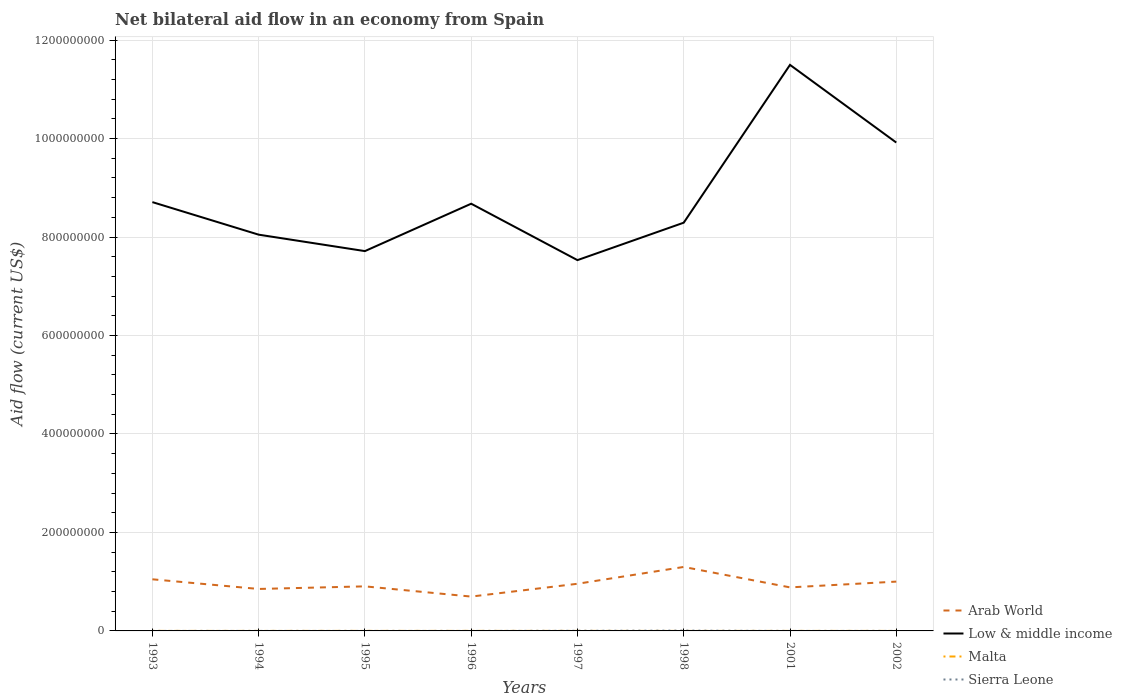In which year was the net bilateral aid flow in Arab World maximum?
Give a very brief answer. 1996. What is the total net bilateral aid flow in Sierra Leone in the graph?
Provide a succinct answer. -2.70e+05. What is the difference between the highest and the second highest net bilateral aid flow in Arab World?
Your response must be concise. 6.02e+07. Does the graph contain grids?
Your answer should be very brief. Yes. How many legend labels are there?
Your answer should be very brief. 4. How are the legend labels stacked?
Provide a succinct answer. Vertical. What is the title of the graph?
Offer a terse response. Net bilateral aid flow in an economy from Spain. Does "Iceland" appear as one of the legend labels in the graph?
Offer a terse response. No. What is the label or title of the X-axis?
Provide a short and direct response. Years. What is the Aid flow (current US$) of Arab World in 1993?
Your response must be concise. 1.05e+08. What is the Aid flow (current US$) in Low & middle income in 1993?
Provide a short and direct response. 8.71e+08. What is the Aid flow (current US$) in Malta in 1993?
Offer a very short reply. 5.00e+04. What is the Aid flow (current US$) in Arab World in 1994?
Provide a succinct answer. 8.52e+07. What is the Aid flow (current US$) in Low & middle income in 1994?
Your answer should be very brief. 8.05e+08. What is the Aid flow (current US$) in Malta in 1994?
Offer a very short reply. 4.00e+04. What is the Aid flow (current US$) in Sierra Leone in 1994?
Your answer should be compact. 2.00e+04. What is the Aid flow (current US$) in Arab World in 1995?
Offer a very short reply. 9.05e+07. What is the Aid flow (current US$) of Low & middle income in 1995?
Your response must be concise. 7.71e+08. What is the Aid flow (current US$) of Sierra Leone in 1995?
Keep it short and to the point. 3.00e+04. What is the Aid flow (current US$) in Arab World in 1996?
Keep it short and to the point. 6.98e+07. What is the Aid flow (current US$) of Low & middle income in 1996?
Provide a short and direct response. 8.68e+08. What is the Aid flow (current US$) in Arab World in 1997?
Your answer should be compact. 9.58e+07. What is the Aid flow (current US$) in Low & middle income in 1997?
Your answer should be compact. 7.53e+08. What is the Aid flow (current US$) in Malta in 1997?
Your response must be concise. 6.00e+04. What is the Aid flow (current US$) of Sierra Leone in 1997?
Offer a terse response. 3.00e+05. What is the Aid flow (current US$) of Arab World in 1998?
Offer a very short reply. 1.30e+08. What is the Aid flow (current US$) of Low & middle income in 1998?
Offer a terse response. 8.29e+08. What is the Aid flow (current US$) in Sierra Leone in 1998?
Offer a very short reply. 6.40e+05. What is the Aid flow (current US$) of Arab World in 2001?
Make the answer very short. 8.84e+07. What is the Aid flow (current US$) of Low & middle income in 2001?
Offer a very short reply. 1.15e+09. What is the Aid flow (current US$) of Arab World in 2002?
Your answer should be compact. 1.00e+08. What is the Aid flow (current US$) of Low & middle income in 2002?
Keep it short and to the point. 9.92e+08. What is the Aid flow (current US$) in Malta in 2002?
Give a very brief answer. 2.00e+04. Across all years, what is the maximum Aid flow (current US$) of Arab World?
Provide a short and direct response. 1.30e+08. Across all years, what is the maximum Aid flow (current US$) of Low & middle income?
Provide a succinct answer. 1.15e+09. Across all years, what is the maximum Aid flow (current US$) in Sierra Leone?
Provide a succinct answer. 6.40e+05. Across all years, what is the minimum Aid flow (current US$) in Arab World?
Your response must be concise. 6.98e+07. Across all years, what is the minimum Aid flow (current US$) of Low & middle income?
Your answer should be compact. 7.53e+08. Across all years, what is the minimum Aid flow (current US$) in Malta?
Make the answer very short. 10000. Across all years, what is the minimum Aid flow (current US$) of Sierra Leone?
Give a very brief answer. 10000. What is the total Aid flow (current US$) in Arab World in the graph?
Make the answer very short. 7.65e+08. What is the total Aid flow (current US$) in Low & middle income in the graph?
Offer a terse response. 7.04e+09. What is the total Aid flow (current US$) in Sierra Leone in the graph?
Your answer should be compact. 1.12e+06. What is the difference between the Aid flow (current US$) in Arab World in 1993 and that in 1994?
Your answer should be very brief. 1.96e+07. What is the difference between the Aid flow (current US$) of Low & middle income in 1993 and that in 1994?
Make the answer very short. 6.61e+07. What is the difference between the Aid flow (current US$) in Malta in 1993 and that in 1994?
Keep it short and to the point. 10000. What is the difference between the Aid flow (current US$) in Sierra Leone in 1993 and that in 1994?
Provide a succinct answer. 10000. What is the difference between the Aid flow (current US$) in Arab World in 1993 and that in 1995?
Offer a terse response. 1.43e+07. What is the difference between the Aid flow (current US$) of Low & middle income in 1993 and that in 1995?
Keep it short and to the point. 9.95e+07. What is the difference between the Aid flow (current US$) in Arab World in 1993 and that in 1996?
Your response must be concise. 3.51e+07. What is the difference between the Aid flow (current US$) of Low & middle income in 1993 and that in 1996?
Make the answer very short. 3.26e+06. What is the difference between the Aid flow (current US$) of Malta in 1993 and that in 1996?
Keep it short and to the point. -3.00e+04. What is the difference between the Aid flow (current US$) in Sierra Leone in 1993 and that in 1996?
Provide a succinct answer. 2.00e+04. What is the difference between the Aid flow (current US$) in Arab World in 1993 and that in 1997?
Offer a very short reply. 9.08e+06. What is the difference between the Aid flow (current US$) of Low & middle income in 1993 and that in 1997?
Offer a terse response. 1.18e+08. What is the difference between the Aid flow (current US$) of Malta in 1993 and that in 1997?
Offer a very short reply. -10000. What is the difference between the Aid flow (current US$) in Sierra Leone in 1993 and that in 1997?
Offer a very short reply. -2.70e+05. What is the difference between the Aid flow (current US$) of Arab World in 1993 and that in 1998?
Keep it short and to the point. -2.51e+07. What is the difference between the Aid flow (current US$) in Low & middle income in 1993 and that in 1998?
Your response must be concise. 4.18e+07. What is the difference between the Aid flow (current US$) of Malta in 1993 and that in 1998?
Give a very brief answer. 4.00e+04. What is the difference between the Aid flow (current US$) in Sierra Leone in 1993 and that in 1998?
Give a very brief answer. -6.10e+05. What is the difference between the Aid flow (current US$) of Arab World in 1993 and that in 2001?
Your answer should be very brief. 1.64e+07. What is the difference between the Aid flow (current US$) in Low & middle income in 1993 and that in 2001?
Your response must be concise. -2.79e+08. What is the difference between the Aid flow (current US$) in Arab World in 1993 and that in 2002?
Your response must be concise. 4.70e+06. What is the difference between the Aid flow (current US$) in Low & middle income in 1993 and that in 2002?
Provide a succinct answer. -1.21e+08. What is the difference between the Aid flow (current US$) of Malta in 1993 and that in 2002?
Make the answer very short. 3.00e+04. What is the difference between the Aid flow (current US$) of Sierra Leone in 1993 and that in 2002?
Provide a succinct answer. -5.00e+04. What is the difference between the Aid flow (current US$) of Arab World in 1994 and that in 1995?
Your answer should be compact. -5.29e+06. What is the difference between the Aid flow (current US$) in Low & middle income in 1994 and that in 1995?
Your response must be concise. 3.34e+07. What is the difference between the Aid flow (current US$) of Malta in 1994 and that in 1995?
Offer a very short reply. -2.00e+04. What is the difference between the Aid flow (current US$) of Sierra Leone in 1994 and that in 1995?
Make the answer very short. -10000. What is the difference between the Aid flow (current US$) of Arab World in 1994 and that in 1996?
Provide a succinct answer. 1.55e+07. What is the difference between the Aid flow (current US$) in Low & middle income in 1994 and that in 1996?
Provide a short and direct response. -6.28e+07. What is the difference between the Aid flow (current US$) of Arab World in 1994 and that in 1997?
Keep it short and to the point. -1.05e+07. What is the difference between the Aid flow (current US$) of Low & middle income in 1994 and that in 1997?
Provide a succinct answer. 5.17e+07. What is the difference between the Aid flow (current US$) in Sierra Leone in 1994 and that in 1997?
Keep it short and to the point. -2.80e+05. What is the difference between the Aid flow (current US$) of Arab World in 1994 and that in 1998?
Your answer should be very brief. -4.47e+07. What is the difference between the Aid flow (current US$) in Low & middle income in 1994 and that in 1998?
Give a very brief answer. -2.43e+07. What is the difference between the Aid flow (current US$) of Malta in 1994 and that in 1998?
Provide a short and direct response. 3.00e+04. What is the difference between the Aid flow (current US$) in Sierra Leone in 1994 and that in 1998?
Your answer should be very brief. -6.20e+05. What is the difference between the Aid flow (current US$) of Arab World in 1994 and that in 2001?
Provide a succinct answer. -3.20e+06. What is the difference between the Aid flow (current US$) in Low & middle income in 1994 and that in 2001?
Give a very brief answer. -3.45e+08. What is the difference between the Aid flow (current US$) in Sierra Leone in 1994 and that in 2001?
Your answer should be very brief. 10000. What is the difference between the Aid flow (current US$) of Arab World in 1994 and that in 2002?
Make the answer very short. -1.49e+07. What is the difference between the Aid flow (current US$) of Low & middle income in 1994 and that in 2002?
Give a very brief answer. -1.87e+08. What is the difference between the Aid flow (current US$) of Sierra Leone in 1994 and that in 2002?
Offer a terse response. -6.00e+04. What is the difference between the Aid flow (current US$) in Arab World in 1995 and that in 1996?
Your response must be concise. 2.08e+07. What is the difference between the Aid flow (current US$) in Low & middle income in 1995 and that in 1996?
Offer a terse response. -9.62e+07. What is the difference between the Aid flow (current US$) in Malta in 1995 and that in 1996?
Your response must be concise. -2.00e+04. What is the difference between the Aid flow (current US$) in Arab World in 1995 and that in 1997?
Keep it short and to the point. -5.25e+06. What is the difference between the Aid flow (current US$) in Low & middle income in 1995 and that in 1997?
Ensure brevity in your answer.  1.83e+07. What is the difference between the Aid flow (current US$) in Malta in 1995 and that in 1997?
Your answer should be very brief. 0. What is the difference between the Aid flow (current US$) of Sierra Leone in 1995 and that in 1997?
Ensure brevity in your answer.  -2.70e+05. What is the difference between the Aid flow (current US$) in Arab World in 1995 and that in 1998?
Provide a short and direct response. -3.94e+07. What is the difference between the Aid flow (current US$) in Low & middle income in 1995 and that in 1998?
Make the answer very short. -5.77e+07. What is the difference between the Aid flow (current US$) of Sierra Leone in 1995 and that in 1998?
Offer a very short reply. -6.10e+05. What is the difference between the Aid flow (current US$) in Arab World in 1995 and that in 2001?
Provide a short and direct response. 2.09e+06. What is the difference between the Aid flow (current US$) in Low & middle income in 1995 and that in 2001?
Offer a very short reply. -3.78e+08. What is the difference between the Aid flow (current US$) in Malta in 1995 and that in 2001?
Offer a terse response. 3.00e+04. What is the difference between the Aid flow (current US$) in Sierra Leone in 1995 and that in 2001?
Provide a succinct answer. 2.00e+04. What is the difference between the Aid flow (current US$) of Arab World in 1995 and that in 2002?
Provide a succinct answer. -9.63e+06. What is the difference between the Aid flow (current US$) in Low & middle income in 1995 and that in 2002?
Provide a short and direct response. -2.20e+08. What is the difference between the Aid flow (current US$) in Malta in 1995 and that in 2002?
Keep it short and to the point. 4.00e+04. What is the difference between the Aid flow (current US$) in Sierra Leone in 1995 and that in 2002?
Provide a short and direct response. -5.00e+04. What is the difference between the Aid flow (current US$) in Arab World in 1996 and that in 1997?
Provide a succinct answer. -2.60e+07. What is the difference between the Aid flow (current US$) of Low & middle income in 1996 and that in 1997?
Ensure brevity in your answer.  1.15e+08. What is the difference between the Aid flow (current US$) in Malta in 1996 and that in 1997?
Ensure brevity in your answer.  2.00e+04. What is the difference between the Aid flow (current US$) in Sierra Leone in 1996 and that in 1997?
Provide a succinct answer. -2.90e+05. What is the difference between the Aid flow (current US$) of Arab World in 1996 and that in 1998?
Provide a succinct answer. -6.02e+07. What is the difference between the Aid flow (current US$) of Low & middle income in 1996 and that in 1998?
Give a very brief answer. 3.85e+07. What is the difference between the Aid flow (current US$) of Malta in 1996 and that in 1998?
Your answer should be compact. 7.00e+04. What is the difference between the Aid flow (current US$) in Sierra Leone in 1996 and that in 1998?
Your answer should be compact. -6.30e+05. What is the difference between the Aid flow (current US$) of Arab World in 1996 and that in 2001?
Make the answer very short. -1.87e+07. What is the difference between the Aid flow (current US$) in Low & middle income in 1996 and that in 2001?
Make the answer very short. -2.82e+08. What is the difference between the Aid flow (current US$) of Arab World in 1996 and that in 2002?
Make the answer very short. -3.04e+07. What is the difference between the Aid flow (current US$) in Low & middle income in 1996 and that in 2002?
Offer a very short reply. -1.24e+08. What is the difference between the Aid flow (current US$) of Arab World in 1997 and that in 1998?
Offer a very short reply. -3.42e+07. What is the difference between the Aid flow (current US$) in Low & middle income in 1997 and that in 1998?
Keep it short and to the point. -7.60e+07. What is the difference between the Aid flow (current US$) in Malta in 1997 and that in 1998?
Offer a terse response. 5.00e+04. What is the difference between the Aid flow (current US$) of Sierra Leone in 1997 and that in 1998?
Ensure brevity in your answer.  -3.40e+05. What is the difference between the Aid flow (current US$) of Arab World in 1997 and that in 2001?
Offer a very short reply. 7.34e+06. What is the difference between the Aid flow (current US$) of Low & middle income in 1997 and that in 2001?
Offer a terse response. -3.97e+08. What is the difference between the Aid flow (current US$) of Arab World in 1997 and that in 2002?
Make the answer very short. -4.38e+06. What is the difference between the Aid flow (current US$) in Low & middle income in 1997 and that in 2002?
Provide a succinct answer. -2.39e+08. What is the difference between the Aid flow (current US$) of Malta in 1997 and that in 2002?
Offer a very short reply. 4.00e+04. What is the difference between the Aid flow (current US$) in Arab World in 1998 and that in 2001?
Keep it short and to the point. 4.15e+07. What is the difference between the Aid flow (current US$) in Low & middle income in 1998 and that in 2001?
Give a very brief answer. -3.20e+08. What is the difference between the Aid flow (current US$) of Malta in 1998 and that in 2001?
Give a very brief answer. -2.00e+04. What is the difference between the Aid flow (current US$) of Sierra Leone in 1998 and that in 2001?
Provide a succinct answer. 6.30e+05. What is the difference between the Aid flow (current US$) of Arab World in 1998 and that in 2002?
Keep it short and to the point. 2.98e+07. What is the difference between the Aid flow (current US$) of Low & middle income in 1998 and that in 2002?
Provide a succinct answer. -1.63e+08. What is the difference between the Aid flow (current US$) in Malta in 1998 and that in 2002?
Provide a short and direct response. -10000. What is the difference between the Aid flow (current US$) in Sierra Leone in 1998 and that in 2002?
Your answer should be compact. 5.60e+05. What is the difference between the Aid flow (current US$) in Arab World in 2001 and that in 2002?
Your response must be concise. -1.17e+07. What is the difference between the Aid flow (current US$) in Low & middle income in 2001 and that in 2002?
Provide a succinct answer. 1.58e+08. What is the difference between the Aid flow (current US$) in Malta in 2001 and that in 2002?
Offer a very short reply. 10000. What is the difference between the Aid flow (current US$) in Sierra Leone in 2001 and that in 2002?
Provide a succinct answer. -7.00e+04. What is the difference between the Aid flow (current US$) in Arab World in 1993 and the Aid flow (current US$) in Low & middle income in 1994?
Your answer should be compact. -7.00e+08. What is the difference between the Aid flow (current US$) in Arab World in 1993 and the Aid flow (current US$) in Malta in 1994?
Provide a succinct answer. 1.05e+08. What is the difference between the Aid flow (current US$) of Arab World in 1993 and the Aid flow (current US$) of Sierra Leone in 1994?
Provide a succinct answer. 1.05e+08. What is the difference between the Aid flow (current US$) in Low & middle income in 1993 and the Aid flow (current US$) in Malta in 1994?
Make the answer very short. 8.71e+08. What is the difference between the Aid flow (current US$) of Low & middle income in 1993 and the Aid flow (current US$) of Sierra Leone in 1994?
Give a very brief answer. 8.71e+08. What is the difference between the Aid flow (current US$) in Arab World in 1993 and the Aid flow (current US$) in Low & middle income in 1995?
Provide a short and direct response. -6.67e+08. What is the difference between the Aid flow (current US$) in Arab World in 1993 and the Aid flow (current US$) in Malta in 1995?
Your response must be concise. 1.05e+08. What is the difference between the Aid flow (current US$) in Arab World in 1993 and the Aid flow (current US$) in Sierra Leone in 1995?
Your answer should be compact. 1.05e+08. What is the difference between the Aid flow (current US$) of Low & middle income in 1993 and the Aid flow (current US$) of Malta in 1995?
Your response must be concise. 8.71e+08. What is the difference between the Aid flow (current US$) of Low & middle income in 1993 and the Aid flow (current US$) of Sierra Leone in 1995?
Provide a short and direct response. 8.71e+08. What is the difference between the Aid flow (current US$) in Arab World in 1993 and the Aid flow (current US$) in Low & middle income in 1996?
Keep it short and to the point. -7.63e+08. What is the difference between the Aid flow (current US$) of Arab World in 1993 and the Aid flow (current US$) of Malta in 1996?
Make the answer very short. 1.05e+08. What is the difference between the Aid flow (current US$) in Arab World in 1993 and the Aid flow (current US$) in Sierra Leone in 1996?
Provide a succinct answer. 1.05e+08. What is the difference between the Aid flow (current US$) in Low & middle income in 1993 and the Aid flow (current US$) in Malta in 1996?
Ensure brevity in your answer.  8.71e+08. What is the difference between the Aid flow (current US$) in Low & middle income in 1993 and the Aid flow (current US$) in Sierra Leone in 1996?
Offer a terse response. 8.71e+08. What is the difference between the Aid flow (current US$) of Malta in 1993 and the Aid flow (current US$) of Sierra Leone in 1996?
Provide a short and direct response. 4.00e+04. What is the difference between the Aid flow (current US$) in Arab World in 1993 and the Aid flow (current US$) in Low & middle income in 1997?
Provide a short and direct response. -6.48e+08. What is the difference between the Aid flow (current US$) of Arab World in 1993 and the Aid flow (current US$) of Malta in 1997?
Your response must be concise. 1.05e+08. What is the difference between the Aid flow (current US$) of Arab World in 1993 and the Aid flow (current US$) of Sierra Leone in 1997?
Your response must be concise. 1.05e+08. What is the difference between the Aid flow (current US$) in Low & middle income in 1993 and the Aid flow (current US$) in Malta in 1997?
Ensure brevity in your answer.  8.71e+08. What is the difference between the Aid flow (current US$) of Low & middle income in 1993 and the Aid flow (current US$) of Sierra Leone in 1997?
Make the answer very short. 8.71e+08. What is the difference between the Aid flow (current US$) in Arab World in 1993 and the Aid flow (current US$) in Low & middle income in 1998?
Keep it short and to the point. -7.24e+08. What is the difference between the Aid flow (current US$) of Arab World in 1993 and the Aid flow (current US$) of Malta in 1998?
Give a very brief answer. 1.05e+08. What is the difference between the Aid flow (current US$) of Arab World in 1993 and the Aid flow (current US$) of Sierra Leone in 1998?
Provide a succinct answer. 1.04e+08. What is the difference between the Aid flow (current US$) in Low & middle income in 1993 and the Aid flow (current US$) in Malta in 1998?
Provide a short and direct response. 8.71e+08. What is the difference between the Aid flow (current US$) in Low & middle income in 1993 and the Aid flow (current US$) in Sierra Leone in 1998?
Your response must be concise. 8.70e+08. What is the difference between the Aid flow (current US$) of Malta in 1993 and the Aid flow (current US$) of Sierra Leone in 1998?
Ensure brevity in your answer.  -5.90e+05. What is the difference between the Aid flow (current US$) of Arab World in 1993 and the Aid flow (current US$) of Low & middle income in 2001?
Offer a terse response. -1.04e+09. What is the difference between the Aid flow (current US$) in Arab World in 1993 and the Aid flow (current US$) in Malta in 2001?
Provide a short and direct response. 1.05e+08. What is the difference between the Aid flow (current US$) in Arab World in 1993 and the Aid flow (current US$) in Sierra Leone in 2001?
Your answer should be compact. 1.05e+08. What is the difference between the Aid flow (current US$) of Low & middle income in 1993 and the Aid flow (current US$) of Malta in 2001?
Ensure brevity in your answer.  8.71e+08. What is the difference between the Aid flow (current US$) in Low & middle income in 1993 and the Aid flow (current US$) in Sierra Leone in 2001?
Your answer should be compact. 8.71e+08. What is the difference between the Aid flow (current US$) of Arab World in 1993 and the Aid flow (current US$) of Low & middle income in 2002?
Your response must be concise. -8.87e+08. What is the difference between the Aid flow (current US$) of Arab World in 1993 and the Aid flow (current US$) of Malta in 2002?
Provide a succinct answer. 1.05e+08. What is the difference between the Aid flow (current US$) in Arab World in 1993 and the Aid flow (current US$) in Sierra Leone in 2002?
Provide a succinct answer. 1.05e+08. What is the difference between the Aid flow (current US$) of Low & middle income in 1993 and the Aid flow (current US$) of Malta in 2002?
Ensure brevity in your answer.  8.71e+08. What is the difference between the Aid flow (current US$) of Low & middle income in 1993 and the Aid flow (current US$) of Sierra Leone in 2002?
Make the answer very short. 8.71e+08. What is the difference between the Aid flow (current US$) in Arab World in 1994 and the Aid flow (current US$) in Low & middle income in 1995?
Your answer should be very brief. -6.86e+08. What is the difference between the Aid flow (current US$) in Arab World in 1994 and the Aid flow (current US$) in Malta in 1995?
Provide a short and direct response. 8.52e+07. What is the difference between the Aid flow (current US$) of Arab World in 1994 and the Aid flow (current US$) of Sierra Leone in 1995?
Your response must be concise. 8.52e+07. What is the difference between the Aid flow (current US$) of Low & middle income in 1994 and the Aid flow (current US$) of Malta in 1995?
Keep it short and to the point. 8.05e+08. What is the difference between the Aid flow (current US$) of Low & middle income in 1994 and the Aid flow (current US$) of Sierra Leone in 1995?
Make the answer very short. 8.05e+08. What is the difference between the Aid flow (current US$) in Arab World in 1994 and the Aid flow (current US$) in Low & middle income in 1996?
Give a very brief answer. -7.82e+08. What is the difference between the Aid flow (current US$) of Arab World in 1994 and the Aid flow (current US$) of Malta in 1996?
Make the answer very short. 8.51e+07. What is the difference between the Aid flow (current US$) in Arab World in 1994 and the Aid flow (current US$) in Sierra Leone in 1996?
Ensure brevity in your answer.  8.52e+07. What is the difference between the Aid flow (current US$) in Low & middle income in 1994 and the Aid flow (current US$) in Malta in 1996?
Your answer should be compact. 8.05e+08. What is the difference between the Aid flow (current US$) in Low & middle income in 1994 and the Aid flow (current US$) in Sierra Leone in 1996?
Keep it short and to the point. 8.05e+08. What is the difference between the Aid flow (current US$) of Malta in 1994 and the Aid flow (current US$) of Sierra Leone in 1996?
Give a very brief answer. 3.00e+04. What is the difference between the Aid flow (current US$) of Arab World in 1994 and the Aid flow (current US$) of Low & middle income in 1997?
Provide a short and direct response. -6.68e+08. What is the difference between the Aid flow (current US$) in Arab World in 1994 and the Aid flow (current US$) in Malta in 1997?
Ensure brevity in your answer.  8.52e+07. What is the difference between the Aid flow (current US$) in Arab World in 1994 and the Aid flow (current US$) in Sierra Leone in 1997?
Offer a very short reply. 8.49e+07. What is the difference between the Aid flow (current US$) of Low & middle income in 1994 and the Aid flow (current US$) of Malta in 1997?
Your answer should be compact. 8.05e+08. What is the difference between the Aid flow (current US$) of Low & middle income in 1994 and the Aid flow (current US$) of Sierra Leone in 1997?
Your answer should be very brief. 8.04e+08. What is the difference between the Aid flow (current US$) of Malta in 1994 and the Aid flow (current US$) of Sierra Leone in 1997?
Your answer should be compact. -2.60e+05. What is the difference between the Aid flow (current US$) of Arab World in 1994 and the Aid flow (current US$) of Low & middle income in 1998?
Ensure brevity in your answer.  -7.44e+08. What is the difference between the Aid flow (current US$) of Arab World in 1994 and the Aid flow (current US$) of Malta in 1998?
Offer a terse response. 8.52e+07. What is the difference between the Aid flow (current US$) in Arab World in 1994 and the Aid flow (current US$) in Sierra Leone in 1998?
Make the answer very short. 8.46e+07. What is the difference between the Aid flow (current US$) of Low & middle income in 1994 and the Aid flow (current US$) of Malta in 1998?
Make the answer very short. 8.05e+08. What is the difference between the Aid flow (current US$) in Low & middle income in 1994 and the Aid flow (current US$) in Sierra Leone in 1998?
Make the answer very short. 8.04e+08. What is the difference between the Aid flow (current US$) in Malta in 1994 and the Aid flow (current US$) in Sierra Leone in 1998?
Your response must be concise. -6.00e+05. What is the difference between the Aid flow (current US$) of Arab World in 1994 and the Aid flow (current US$) of Low & middle income in 2001?
Offer a terse response. -1.06e+09. What is the difference between the Aid flow (current US$) of Arab World in 1994 and the Aid flow (current US$) of Malta in 2001?
Your answer should be very brief. 8.52e+07. What is the difference between the Aid flow (current US$) of Arab World in 1994 and the Aid flow (current US$) of Sierra Leone in 2001?
Make the answer very short. 8.52e+07. What is the difference between the Aid flow (current US$) of Low & middle income in 1994 and the Aid flow (current US$) of Malta in 2001?
Ensure brevity in your answer.  8.05e+08. What is the difference between the Aid flow (current US$) of Low & middle income in 1994 and the Aid flow (current US$) of Sierra Leone in 2001?
Give a very brief answer. 8.05e+08. What is the difference between the Aid flow (current US$) in Malta in 1994 and the Aid flow (current US$) in Sierra Leone in 2001?
Your response must be concise. 3.00e+04. What is the difference between the Aid flow (current US$) in Arab World in 1994 and the Aid flow (current US$) in Low & middle income in 2002?
Your answer should be very brief. -9.07e+08. What is the difference between the Aid flow (current US$) in Arab World in 1994 and the Aid flow (current US$) in Malta in 2002?
Your answer should be compact. 8.52e+07. What is the difference between the Aid flow (current US$) in Arab World in 1994 and the Aid flow (current US$) in Sierra Leone in 2002?
Make the answer very short. 8.51e+07. What is the difference between the Aid flow (current US$) of Low & middle income in 1994 and the Aid flow (current US$) of Malta in 2002?
Keep it short and to the point. 8.05e+08. What is the difference between the Aid flow (current US$) in Low & middle income in 1994 and the Aid flow (current US$) in Sierra Leone in 2002?
Keep it short and to the point. 8.05e+08. What is the difference between the Aid flow (current US$) of Arab World in 1995 and the Aid flow (current US$) of Low & middle income in 1996?
Provide a short and direct response. -7.77e+08. What is the difference between the Aid flow (current US$) in Arab World in 1995 and the Aid flow (current US$) in Malta in 1996?
Offer a very short reply. 9.04e+07. What is the difference between the Aid flow (current US$) of Arab World in 1995 and the Aid flow (current US$) of Sierra Leone in 1996?
Offer a very short reply. 9.05e+07. What is the difference between the Aid flow (current US$) in Low & middle income in 1995 and the Aid flow (current US$) in Malta in 1996?
Provide a succinct answer. 7.71e+08. What is the difference between the Aid flow (current US$) of Low & middle income in 1995 and the Aid flow (current US$) of Sierra Leone in 1996?
Your answer should be compact. 7.71e+08. What is the difference between the Aid flow (current US$) in Malta in 1995 and the Aid flow (current US$) in Sierra Leone in 1996?
Make the answer very short. 5.00e+04. What is the difference between the Aid flow (current US$) of Arab World in 1995 and the Aid flow (current US$) of Low & middle income in 1997?
Make the answer very short. -6.63e+08. What is the difference between the Aid flow (current US$) of Arab World in 1995 and the Aid flow (current US$) of Malta in 1997?
Provide a succinct answer. 9.04e+07. What is the difference between the Aid flow (current US$) of Arab World in 1995 and the Aid flow (current US$) of Sierra Leone in 1997?
Ensure brevity in your answer.  9.02e+07. What is the difference between the Aid flow (current US$) of Low & middle income in 1995 and the Aid flow (current US$) of Malta in 1997?
Your answer should be very brief. 7.71e+08. What is the difference between the Aid flow (current US$) in Low & middle income in 1995 and the Aid flow (current US$) in Sierra Leone in 1997?
Offer a terse response. 7.71e+08. What is the difference between the Aid flow (current US$) of Malta in 1995 and the Aid flow (current US$) of Sierra Leone in 1997?
Provide a succinct answer. -2.40e+05. What is the difference between the Aid flow (current US$) of Arab World in 1995 and the Aid flow (current US$) of Low & middle income in 1998?
Your response must be concise. -7.39e+08. What is the difference between the Aid flow (current US$) in Arab World in 1995 and the Aid flow (current US$) in Malta in 1998?
Keep it short and to the point. 9.05e+07. What is the difference between the Aid flow (current US$) of Arab World in 1995 and the Aid flow (current US$) of Sierra Leone in 1998?
Provide a succinct answer. 8.99e+07. What is the difference between the Aid flow (current US$) in Low & middle income in 1995 and the Aid flow (current US$) in Malta in 1998?
Keep it short and to the point. 7.71e+08. What is the difference between the Aid flow (current US$) of Low & middle income in 1995 and the Aid flow (current US$) of Sierra Leone in 1998?
Offer a terse response. 7.71e+08. What is the difference between the Aid flow (current US$) of Malta in 1995 and the Aid flow (current US$) of Sierra Leone in 1998?
Your answer should be very brief. -5.80e+05. What is the difference between the Aid flow (current US$) of Arab World in 1995 and the Aid flow (current US$) of Low & middle income in 2001?
Provide a short and direct response. -1.06e+09. What is the difference between the Aid flow (current US$) in Arab World in 1995 and the Aid flow (current US$) in Malta in 2001?
Offer a very short reply. 9.05e+07. What is the difference between the Aid flow (current US$) of Arab World in 1995 and the Aid flow (current US$) of Sierra Leone in 2001?
Provide a short and direct response. 9.05e+07. What is the difference between the Aid flow (current US$) of Low & middle income in 1995 and the Aid flow (current US$) of Malta in 2001?
Offer a very short reply. 7.71e+08. What is the difference between the Aid flow (current US$) in Low & middle income in 1995 and the Aid flow (current US$) in Sierra Leone in 2001?
Offer a very short reply. 7.71e+08. What is the difference between the Aid flow (current US$) of Malta in 1995 and the Aid flow (current US$) of Sierra Leone in 2001?
Ensure brevity in your answer.  5.00e+04. What is the difference between the Aid flow (current US$) in Arab World in 1995 and the Aid flow (current US$) in Low & middle income in 2002?
Ensure brevity in your answer.  -9.01e+08. What is the difference between the Aid flow (current US$) of Arab World in 1995 and the Aid flow (current US$) of Malta in 2002?
Make the answer very short. 9.05e+07. What is the difference between the Aid flow (current US$) in Arab World in 1995 and the Aid flow (current US$) in Sierra Leone in 2002?
Your answer should be very brief. 9.04e+07. What is the difference between the Aid flow (current US$) of Low & middle income in 1995 and the Aid flow (current US$) of Malta in 2002?
Provide a short and direct response. 7.71e+08. What is the difference between the Aid flow (current US$) in Low & middle income in 1995 and the Aid flow (current US$) in Sierra Leone in 2002?
Provide a succinct answer. 7.71e+08. What is the difference between the Aid flow (current US$) in Arab World in 1996 and the Aid flow (current US$) in Low & middle income in 1997?
Your response must be concise. -6.83e+08. What is the difference between the Aid flow (current US$) in Arab World in 1996 and the Aid flow (current US$) in Malta in 1997?
Your answer should be compact. 6.97e+07. What is the difference between the Aid flow (current US$) of Arab World in 1996 and the Aid flow (current US$) of Sierra Leone in 1997?
Give a very brief answer. 6.94e+07. What is the difference between the Aid flow (current US$) in Low & middle income in 1996 and the Aid flow (current US$) in Malta in 1997?
Offer a terse response. 8.68e+08. What is the difference between the Aid flow (current US$) of Low & middle income in 1996 and the Aid flow (current US$) of Sierra Leone in 1997?
Offer a terse response. 8.67e+08. What is the difference between the Aid flow (current US$) in Arab World in 1996 and the Aid flow (current US$) in Low & middle income in 1998?
Your response must be concise. -7.59e+08. What is the difference between the Aid flow (current US$) in Arab World in 1996 and the Aid flow (current US$) in Malta in 1998?
Ensure brevity in your answer.  6.97e+07. What is the difference between the Aid flow (current US$) in Arab World in 1996 and the Aid flow (current US$) in Sierra Leone in 1998?
Provide a succinct answer. 6.91e+07. What is the difference between the Aid flow (current US$) of Low & middle income in 1996 and the Aid flow (current US$) of Malta in 1998?
Provide a succinct answer. 8.68e+08. What is the difference between the Aid flow (current US$) of Low & middle income in 1996 and the Aid flow (current US$) of Sierra Leone in 1998?
Provide a succinct answer. 8.67e+08. What is the difference between the Aid flow (current US$) of Malta in 1996 and the Aid flow (current US$) of Sierra Leone in 1998?
Offer a very short reply. -5.60e+05. What is the difference between the Aid flow (current US$) of Arab World in 1996 and the Aid flow (current US$) of Low & middle income in 2001?
Offer a very short reply. -1.08e+09. What is the difference between the Aid flow (current US$) of Arab World in 1996 and the Aid flow (current US$) of Malta in 2001?
Ensure brevity in your answer.  6.97e+07. What is the difference between the Aid flow (current US$) of Arab World in 1996 and the Aid flow (current US$) of Sierra Leone in 2001?
Your answer should be compact. 6.97e+07. What is the difference between the Aid flow (current US$) of Low & middle income in 1996 and the Aid flow (current US$) of Malta in 2001?
Your response must be concise. 8.68e+08. What is the difference between the Aid flow (current US$) of Low & middle income in 1996 and the Aid flow (current US$) of Sierra Leone in 2001?
Make the answer very short. 8.68e+08. What is the difference between the Aid flow (current US$) in Arab World in 1996 and the Aid flow (current US$) in Low & middle income in 2002?
Ensure brevity in your answer.  -9.22e+08. What is the difference between the Aid flow (current US$) in Arab World in 1996 and the Aid flow (current US$) in Malta in 2002?
Ensure brevity in your answer.  6.97e+07. What is the difference between the Aid flow (current US$) in Arab World in 1996 and the Aid flow (current US$) in Sierra Leone in 2002?
Keep it short and to the point. 6.97e+07. What is the difference between the Aid flow (current US$) in Low & middle income in 1996 and the Aid flow (current US$) in Malta in 2002?
Offer a very short reply. 8.68e+08. What is the difference between the Aid flow (current US$) of Low & middle income in 1996 and the Aid flow (current US$) of Sierra Leone in 2002?
Provide a succinct answer. 8.68e+08. What is the difference between the Aid flow (current US$) of Arab World in 1997 and the Aid flow (current US$) of Low & middle income in 1998?
Offer a very short reply. -7.33e+08. What is the difference between the Aid flow (current US$) in Arab World in 1997 and the Aid flow (current US$) in Malta in 1998?
Give a very brief answer. 9.58e+07. What is the difference between the Aid flow (current US$) in Arab World in 1997 and the Aid flow (current US$) in Sierra Leone in 1998?
Ensure brevity in your answer.  9.51e+07. What is the difference between the Aid flow (current US$) of Low & middle income in 1997 and the Aid flow (current US$) of Malta in 1998?
Offer a very short reply. 7.53e+08. What is the difference between the Aid flow (current US$) in Low & middle income in 1997 and the Aid flow (current US$) in Sierra Leone in 1998?
Give a very brief answer. 7.52e+08. What is the difference between the Aid flow (current US$) of Malta in 1997 and the Aid flow (current US$) of Sierra Leone in 1998?
Provide a succinct answer. -5.80e+05. What is the difference between the Aid flow (current US$) in Arab World in 1997 and the Aid flow (current US$) in Low & middle income in 2001?
Provide a short and direct response. -1.05e+09. What is the difference between the Aid flow (current US$) of Arab World in 1997 and the Aid flow (current US$) of Malta in 2001?
Keep it short and to the point. 9.57e+07. What is the difference between the Aid flow (current US$) in Arab World in 1997 and the Aid flow (current US$) in Sierra Leone in 2001?
Give a very brief answer. 9.58e+07. What is the difference between the Aid flow (current US$) in Low & middle income in 1997 and the Aid flow (current US$) in Malta in 2001?
Provide a succinct answer. 7.53e+08. What is the difference between the Aid flow (current US$) in Low & middle income in 1997 and the Aid flow (current US$) in Sierra Leone in 2001?
Your answer should be compact. 7.53e+08. What is the difference between the Aid flow (current US$) of Arab World in 1997 and the Aid flow (current US$) of Low & middle income in 2002?
Your response must be concise. -8.96e+08. What is the difference between the Aid flow (current US$) of Arab World in 1997 and the Aid flow (current US$) of Malta in 2002?
Your answer should be very brief. 9.57e+07. What is the difference between the Aid flow (current US$) in Arab World in 1997 and the Aid flow (current US$) in Sierra Leone in 2002?
Your answer should be very brief. 9.57e+07. What is the difference between the Aid flow (current US$) of Low & middle income in 1997 and the Aid flow (current US$) of Malta in 2002?
Make the answer very short. 7.53e+08. What is the difference between the Aid flow (current US$) of Low & middle income in 1997 and the Aid flow (current US$) of Sierra Leone in 2002?
Your answer should be very brief. 7.53e+08. What is the difference between the Aid flow (current US$) in Arab World in 1998 and the Aid flow (current US$) in Low & middle income in 2001?
Your answer should be compact. -1.02e+09. What is the difference between the Aid flow (current US$) in Arab World in 1998 and the Aid flow (current US$) in Malta in 2001?
Keep it short and to the point. 1.30e+08. What is the difference between the Aid flow (current US$) of Arab World in 1998 and the Aid flow (current US$) of Sierra Leone in 2001?
Provide a succinct answer. 1.30e+08. What is the difference between the Aid flow (current US$) of Low & middle income in 1998 and the Aid flow (current US$) of Malta in 2001?
Give a very brief answer. 8.29e+08. What is the difference between the Aid flow (current US$) in Low & middle income in 1998 and the Aid flow (current US$) in Sierra Leone in 2001?
Your answer should be very brief. 8.29e+08. What is the difference between the Aid flow (current US$) in Malta in 1998 and the Aid flow (current US$) in Sierra Leone in 2001?
Your answer should be compact. 0. What is the difference between the Aid flow (current US$) in Arab World in 1998 and the Aid flow (current US$) in Low & middle income in 2002?
Provide a short and direct response. -8.62e+08. What is the difference between the Aid flow (current US$) of Arab World in 1998 and the Aid flow (current US$) of Malta in 2002?
Offer a very short reply. 1.30e+08. What is the difference between the Aid flow (current US$) of Arab World in 1998 and the Aid flow (current US$) of Sierra Leone in 2002?
Your response must be concise. 1.30e+08. What is the difference between the Aid flow (current US$) in Low & middle income in 1998 and the Aid flow (current US$) in Malta in 2002?
Your response must be concise. 8.29e+08. What is the difference between the Aid flow (current US$) of Low & middle income in 1998 and the Aid flow (current US$) of Sierra Leone in 2002?
Your answer should be compact. 8.29e+08. What is the difference between the Aid flow (current US$) of Arab World in 2001 and the Aid flow (current US$) of Low & middle income in 2002?
Your answer should be very brief. -9.03e+08. What is the difference between the Aid flow (current US$) in Arab World in 2001 and the Aid flow (current US$) in Malta in 2002?
Give a very brief answer. 8.84e+07. What is the difference between the Aid flow (current US$) of Arab World in 2001 and the Aid flow (current US$) of Sierra Leone in 2002?
Make the answer very short. 8.83e+07. What is the difference between the Aid flow (current US$) of Low & middle income in 2001 and the Aid flow (current US$) of Malta in 2002?
Ensure brevity in your answer.  1.15e+09. What is the difference between the Aid flow (current US$) in Low & middle income in 2001 and the Aid flow (current US$) in Sierra Leone in 2002?
Provide a short and direct response. 1.15e+09. What is the difference between the Aid flow (current US$) of Malta in 2001 and the Aid flow (current US$) of Sierra Leone in 2002?
Your answer should be compact. -5.00e+04. What is the average Aid flow (current US$) of Arab World per year?
Make the answer very short. 9.56e+07. What is the average Aid flow (current US$) of Low & middle income per year?
Make the answer very short. 8.80e+08. What is the average Aid flow (current US$) in Malta per year?
Your answer should be compact. 4.38e+04. In the year 1993, what is the difference between the Aid flow (current US$) of Arab World and Aid flow (current US$) of Low & middle income?
Ensure brevity in your answer.  -7.66e+08. In the year 1993, what is the difference between the Aid flow (current US$) in Arab World and Aid flow (current US$) in Malta?
Ensure brevity in your answer.  1.05e+08. In the year 1993, what is the difference between the Aid flow (current US$) in Arab World and Aid flow (current US$) in Sierra Leone?
Your response must be concise. 1.05e+08. In the year 1993, what is the difference between the Aid flow (current US$) of Low & middle income and Aid flow (current US$) of Malta?
Your answer should be compact. 8.71e+08. In the year 1993, what is the difference between the Aid flow (current US$) in Low & middle income and Aid flow (current US$) in Sierra Leone?
Provide a short and direct response. 8.71e+08. In the year 1993, what is the difference between the Aid flow (current US$) of Malta and Aid flow (current US$) of Sierra Leone?
Ensure brevity in your answer.  2.00e+04. In the year 1994, what is the difference between the Aid flow (current US$) in Arab World and Aid flow (current US$) in Low & middle income?
Ensure brevity in your answer.  -7.20e+08. In the year 1994, what is the difference between the Aid flow (current US$) of Arab World and Aid flow (current US$) of Malta?
Your answer should be compact. 8.52e+07. In the year 1994, what is the difference between the Aid flow (current US$) of Arab World and Aid flow (current US$) of Sierra Leone?
Provide a short and direct response. 8.52e+07. In the year 1994, what is the difference between the Aid flow (current US$) in Low & middle income and Aid flow (current US$) in Malta?
Make the answer very short. 8.05e+08. In the year 1994, what is the difference between the Aid flow (current US$) in Low & middle income and Aid flow (current US$) in Sierra Leone?
Offer a terse response. 8.05e+08. In the year 1994, what is the difference between the Aid flow (current US$) in Malta and Aid flow (current US$) in Sierra Leone?
Provide a short and direct response. 2.00e+04. In the year 1995, what is the difference between the Aid flow (current US$) in Arab World and Aid flow (current US$) in Low & middle income?
Offer a terse response. -6.81e+08. In the year 1995, what is the difference between the Aid flow (current US$) of Arab World and Aid flow (current US$) of Malta?
Offer a very short reply. 9.04e+07. In the year 1995, what is the difference between the Aid flow (current US$) of Arab World and Aid flow (current US$) of Sierra Leone?
Offer a very short reply. 9.05e+07. In the year 1995, what is the difference between the Aid flow (current US$) of Low & middle income and Aid flow (current US$) of Malta?
Your answer should be compact. 7.71e+08. In the year 1995, what is the difference between the Aid flow (current US$) in Low & middle income and Aid flow (current US$) in Sierra Leone?
Your response must be concise. 7.71e+08. In the year 1995, what is the difference between the Aid flow (current US$) in Malta and Aid flow (current US$) in Sierra Leone?
Offer a terse response. 3.00e+04. In the year 1996, what is the difference between the Aid flow (current US$) in Arab World and Aid flow (current US$) in Low & middle income?
Offer a terse response. -7.98e+08. In the year 1996, what is the difference between the Aid flow (current US$) of Arab World and Aid flow (current US$) of Malta?
Give a very brief answer. 6.97e+07. In the year 1996, what is the difference between the Aid flow (current US$) in Arab World and Aid flow (current US$) in Sierra Leone?
Keep it short and to the point. 6.97e+07. In the year 1996, what is the difference between the Aid flow (current US$) of Low & middle income and Aid flow (current US$) of Malta?
Offer a terse response. 8.68e+08. In the year 1996, what is the difference between the Aid flow (current US$) in Low & middle income and Aid flow (current US$) in Sierra Leone?
Keep it short and to the point. 8.68e+08. In the year 1996, what is the difference between the Aid flow (current US$) of Malta and Aid flow (current US$) of Sierra Leone?
Your response must be concise. 7.00e+04. In the year 1997, what is the difference between the Aid flow (current US$) of Arab World and Aid flow (current US$) of Low & middle income?
Ensure brevity in your answer.  -6.57e+08. In the year 1997, what is the difference between the Aid flow (current US$) of Arab World and Aid flow (current US$) of Malta?
Offer a very short reply. 9.57e+07. In the year 1997, what is the difference between the Aid flow (current US$) in Arab World and Aid flow (current US$) in Sierra Leone?
Your response must be concise. 9.55e+07. In the year 1997, what is the difference between the Aid flow (current US$) in Low & middle income and Aid flow (current US$) in Malta?
Your answer should be compact. 7.53e+08. In the year 1997, what is the difference between the Aid flow (current US$) of Low & middle income and Aid flow (current US$) of Sierra Leone?
Your answer should be compact. 7.53e+08. In the year 1998, what is the difference between the Aid flow (current US$) of Arab World and Aid flow (current US$) of Low & middle income?
Offer a terse response. -6.99e+08. In the year 1998, what is the difference between the Aid flow (current US$) in Arab World and Aid flow (current US$) in Malta?
Offer a terse response. 1.30e+08. In the year 1998, what is the difference between the Aid flow (current US$) in Arab World and Aid flow (current US$) in Sierra Leone?
Offer a very short reply. 1.29e+08. In the year 1998, what is the difference between the Aid flow (current US$) of Low & middle income and Aid flow (current US$) of Malta?
Keep it short and to the point. 8.29e+08. In the year 1998, what is the difference between the Aid flow (current US$) in Low & middle income and Aid flow (current US$) in Sierra Leone?
Provide a succinct answer. 8.28e+08. In the year 1998, what is the difference between the Aid flow (current US$) in Malta and Aid flow (current US$) in Sierra Leone?
Provide a succinct answer. -6.30e+05. In the year 2001, what is the difference between the Aid flow (current US$) in Arab World and Aid flow (current US$) in Low & middle income?
Provide a short and direct response. -1.06e+09. In the year 2001, what is the difference between the Aid flow (current US$) of Arab World and Aid flow (current US$) of Malta?
Ensure brevity in your answer.  8.84e+07. In the year 2001, what is the difference between the Aid flow (current US$) in Arab World and Aid flow (current US$) in Sierra Leone?
Provide a short and direct response. 8.84e+07. In the year 2001, what is the difference between the Aid flow (current US$) in Low & middle income and Aid flow (current US$) in Malta?
Give a very brief answer. 1.15e+09. In the year 2001, what is the difference between the Aid flow (current US$) of Low & middle income and Aid flow (current US$) of Sierra Leone?
Provide a short and direct response. 1.15e+09. In the year 2002, what is the difference between the Aid flow (current US$) of Arab World and Aid flow (current US$) of Low & middle income?
Your answer should be compact. -8.92e+08. In the year 2002, what is the difference between the Aid flow (current US$) of Arab World and Aid flow (current US$) of Malta?
Keep it short and to the point. 1.00e+08. In the year 2002, what is the difference between the Aid flow (current US$) in Arab World and Aid flow (current US$) in Sierra Leone?
Provide a succinct answer. 1.00e+08. In the year 2002, what is the difference between the Aid flow (current US$) in Low & middle income and Aid flow (current US$) in Malta?
Offer a very short reply. 9.92e+08. In the year 2002, what is the difference between the Aid flow (current US$) in Low & middle income and Aid flow (current US$) in Sierra Leone?
Make the answer very short. 9.92e+08. In the year 2002, what is the difference between the Aid flow (current US$) in Malta and Aid flow (current US$) in Sierra Leone?
Your answer should be compact. -6.00e+04. What is the ratio of the Aid flow (current US$) of Arab World in 1993 to that in 1994?
Provide a succinct answer. 1.23. What is the ratio of the Aid flow (current US$) of Low & middle income in 1993 to that in 1994?
Your response must be concise. 1.08. What is the ratio of the Aid flow (current US$) in Arab World in 1993 to that in 1995?
Give a very brief answer. 1.16. What is the ratio of the Aid flow (current US$) of Low & middle income in 1993 to that in 1995?
Give a very brief answer. 1.13. What is the ratio of the Aid flow (current US$) in Malta in 1993 to that in 1995?
Offer a terse response. 0.83. What is the ratio of the Aid flow (current US$) of Arab World in 1993 to that in 1996?
Give a very brief answer. 1.5. What is the ratio of the Aid flow (current US$) of Malta in 1993 to that in 1996?
Your answer should be very brief. 0.62. What is the ratio of the Aid flow (current US$) of Arab World in 1993 to that in 1997?
Ensure brevity in your answer.  1.09. What is the ratio of the Aid flow (current US$) in Low & middle income in 1993 to that in 1997?
Provide a succinct answer. 1.16. What is the ratio of the Aid flow (current US$) of Arab World in 1993 to that in 1998?
Provide a short and direct response. 0.81. What is the ratio of the Aid flow (current US$) in Low & middle income in 1993 to that in 1998?
Keep it short and to the point. 1.05. What is the ratio of the Aid flow (current US$) in Sierra Leone in 1993 to that in 1998?
Give a very brief answer. 0.05. What is the ratio of the Aid flow (current US$) of Arab World in 1993 to that in 2001?
Ensure brevity in your answer.  1.19. What is the ratio of the Aid flow (current US$) in Low & middle income in 1993 to that in 2001?
Ensure brevity in your answer.  0.76. What is the ratio of the Aid flow (current US$) of Arab World in 1993 to that in 2002?
Offer a very short reply. 1.05. What is the ratio of the Aid flow (current US$) of Low & middle income in 1993 to that in 2002?
Give a very brief answer. 0.88. What is the ratio of the Aid flow (current US$) in Sierra Leone in 1993 to that in 2002?
Offer a terse response. 0.38. What is the ratio of the Aid flow (current US$) of Arab World in 1994 to that in 1995?
Provide a short and direct response. 0.94. What is the ratio of the Aid flow (current US$) of Low & middle income in 1994 to that in 1995?
Your response must be concise. 1.04. What is the ratio of the Aid flow (current US$) in Arab World in 1994 to that in 1996?
Make the answer very short. 1.22. What is the ratio of the Aid flow (current US$) of Low & middle income in 1994 to that in 1996?
Provide a short and direct response. 0.93. What is the ratio of the Aid flow (current US$) of Malta in 1994 to that in 1996?
Your response must be concise. 0.5. What is the ratio of the Aid flow (current US$) in Arab World in 1994 to that in 1997?
Give a very brief answer. 0.89. What is the ratio of the Aid flow (current US$) of Low & middle income in 1994 to that in 1997?
Your answer should be very brief. 1.07. What is the ratio of the Aid flow (current US$) in Sierra Leone in 1994 to that in 1997?
Give a very brief answer. 0.07. What is the ratio of the Aid flow (current US$) in Arab World in 1994 to that in 1998?
Make the answer very short. 0.66. What is the ratio of the Aid flow (current US$) in Low & middle income in 1994 to that in 1998?
Provide a short and direct response. 0.97. What is the ratio of the Aid flow (current US$) of Malta in 1994 to that in 1998?
Give a very brief answer. 4. What is the ratio of the Aid flow (current US$) in Sierra Leone in 1994 to that in 1998?
Your response must be concise. 0.03. What is the ratio of the Aid flow (current US$) of Arab World in 1994 to that in 2001?
Provide a short and direct response. 0.96. What is the ratio of the Aid flow (current US$) of Low & middle income in 1994 to that in 2001?
Make the answer very short. 0.7. What is the ratio of the Aid flow (current US$) of Malta in 1994 to that in 2001?
Give a very brief answer. 1.33. What is the ratio of the Aid flow (current US$) in Arab World in 1994 to that in 2002?
Provide a succinct answer. 0.85. What is the ratio of the Aid flow (current US$) in Low & middle income in 1994 to that in 2002?
Your answer should be very brief. 0.81. What is the ratio of the Aid flow (current US$) in Malta in 1994 to that in 2002?
Your response must be concise. 2. What is the ratio of the Aid flow (current US$) of Arab World in 1995 to that in 1996?
Ensure brevity in your answer.  1.3. What is the ratio of the Aid flow (current US$) in Low & middle income in 1995 to that in 1996?
Your answer should be very brief. 0.89. What is the ratio of the Aid flow (current US$) of Arab World in 1995 to that in 1997?
Keep it short and to the point. 0.95. What is the ratio of the Aid flow (current US$) of Low & middle income in 1995 to that in 1997?
Offer a very short reply. 1.02. What is the ratio of the Aid flow (current US$) in Sierra Leone in 1995 to that in 1997?
Your answer should be compact. 0.1. What is the ratio of the Aid flow (current US$) of Arab World in 1995 to that in 1998?
Provide a succinct answer. 0.7. What is the ratio of the Aid flow (current US$) in Low & middle income in 1995 to that in 1998?
Offer a very short reply. 0.93. What is the ratio of the Aid flow (current US$) in Sierra Leone in 1995 to that in 1998?
Your answer should be very brief. 0.05. What is the ratio of the Aid flow (current US$) of Arab World in 1995 to that in 2001?
Your answer should be compact. 1.02. What is the ratio of the Aid flow (current US$) of Low & middle income in 1995 to that in 2001?
Give a very brief answer. 0.67. What is the ratio of the Aid flow (current US$) of Malta in 1995 to that in 2001?
Ensure brevity in your answer.  2. What is the ratio of the Aid flow (current US$) in Sierra Leone in 1995 to that in 2001?
Provide a short and direct response. 3. What is the ratio of the Aid flow (current US$) in Arab World in 1995 to that in 2002?
Your answer should be very brief. 0.9. What is the ratio of the Aid flow (current US$) in Low & middle income in 1995 to that in 2002?
Your answer should be very brief. 0.78. What is the ratio of the Aid flow (current US$) of Arab World in 1996 to that in 1997?
Offer a very short reply. 0.73. What is the ratio of the Aid flow (current US$) of Low & middle income in 1996 to that in 1997?
Your answer should be compact. 1.15. What is the ratio of the Aid flow (current US$) in Sierra Leone in 1996 to that in 1997?
Offer a terse response. 0.03. What is the ratio of the Aid flow (current US$) in Arab World in 1996 to that in 1998?
Offer a very short reply. 0.54. What is the ratio of the Aid flow (current US$) in Low & middle income in 1996 to that in 1998?
Your answer should be very brief. 1.05. What is the ratio of the Aid flow (current US$) in Malta in 1996 to that in 1998?
Make the answer very short. 8. What is the ratio of the Aid flow (current US$) in Sierra Leone in 1996 to that in 1998?
Give a very brief answer. 0.02. What is the ratio of the Aid flow (current US$) of Arab World in 1996 to that in 2001?
Offer a terse response. 0.79. What is the ratio of the Aid flow (current US$) in Low & middle income in 1996 to that in 2001?
Your response must be concise. 0.75. What is the ratio of the Aid flow (current US$) in Malta in 1996 to that in 2001?
Your answer should be compact. 2.67. What is the ratio of the Aid flow (current US$) in Sierra Leone in 1996 to that in 2001?
Provide a succinct answer. 1. What is the ratio of the Aid flow (current US$) in Arab World in 1996 to that in 2002?
Ensure brevity in your answer.  0.7. What is the ratio of the Aid flow (current US$) of Low & middle income in 1996 to that in 2002?
Your answer should be very brief. 0.87. What is the ratio of the Aid flow (current US$) in Malta in 1996 to that in 2002?
Provide a succinct answer. 4. What is the ratio of the Aid flow (current US$) in Arab World in 1997 to that in 1998?
Your answer should be very brief. 0.74. What is the ratio of the Aid flow (current US$) of Low & middle income in 1997 to that in 1998?
Give a very brief answer. 0.91. What is the ratio of the Aid flow (current US$) in Sierra Leone in 1997 to that in 1998?
Provide a short and direct response. 0.47. What is the ratio of the Aid flow (current US$) in Arab World in 1997 to that in 2001?
Provide a succinct answer. 1.08. What is the ratio of the Aid flow (current US$) of Low & middle income in 1997 to that in 2001?
Provide a succinct answer. 0.66. What is the ratio of the Aid flow (current US$) in Sierra Leone in 1997 to that in 2001?
Offer a very short reply. 30. What is the ratio of the Aid flow (current US$) in Arab World in 1997 to that in 2002?
Your answer should be very brief. 0.96. What is the ratio of the Aid flow (current US$) in Low & middle income in 1997 to that in 2002?
Make the answer very short. 0.76. What is the ratio of the Aid flow (current US$) of Sierra Leone in 1997 to that in 2002?
Keep it short and to the point. 3.75. What is the ratio of the Aid flow (current US$) of Arab World in 1998 to that in 2001?
Your response must be concise. 1.47. What is the ratio of the Aid flow (current US$) of Low & middle income in 1998 to that in 2001?
Your answer should be very brief. 0.72. What is the ratio of the Aid flow (current US$) of Malta in 1998 to that in 2001?
Provide a succinct answer. 0.33. What is the ratio of the Aid flow (current US$) in Arab World in 1998 to that in 2002?
Ensure brevity in your answer.  1.3. What is the ratio of the Aid flow (current US$) in Low & middle income in 1998 to that in 2002?
Your answer should be very brief. 0.84. What is the ratio of the Aid flow (current US$) of Sierra Leone in 1998 to that in 2002?
Ensure brevity in your answer.  8. What is the ratio of the Aid flow (current US$) of Arab World in 2001 to that in 2002?
Ensure brevity in your answer.  0.88. What is the ratio of the Aid flow (current US$) in Low & middle income in 2001 to that in 2002?
Give a very brief answer. 1.16. What is the ratio of the Aid flow (current US$) in Malta in 2001 to that in 2002?
Your answer should be compact. 1.5. What is the ratio of the Aid flow (current US$) in Sierra Leone in 2001 to that in 2002?
Provide a short and direct response. 0.12. What is the difference between the highest and the second highest Aid flow (current US$) in Arab World?
Provide a succinct answer. 2.51e+07. What is the difference between the highest and the second highest Aid flow (current US$) in Low & middle income?
Offer a terse response. 1.58e+08. What is the difference between the highest and the second highest Aid flow (current US$) in Sierra Leone?
Make the answer very short. 3.40e+05. What is the difference between the highest and the lowest Aid flow (current US$) in Arab World?
Give a very brief answer. 6.02e+07. What is the difference between the highest and the lowest Aid flow (current US$) of Low & middle income?
Ensure brevity in your answer.  3.97e+08. What is the difference between the highest and the lowest Aid flow (current US$) of Sierra Leone?
Ensure brevity in your answer.  6.30e+05. 